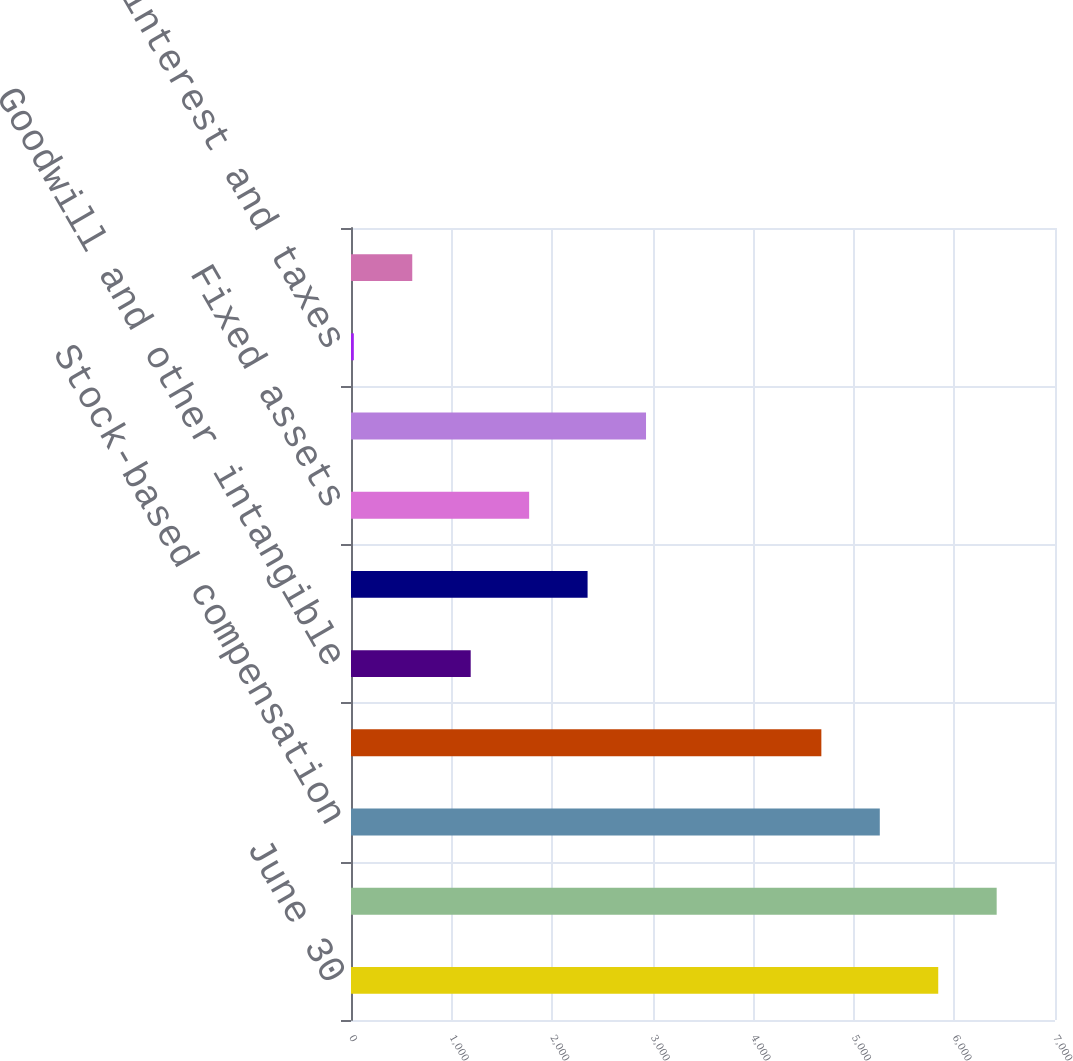Convert chart. <chart><loc_0><loc_0><loc_500><loc_500><bar_chart><fcel>June 30<fcel>Pension and postretirement<fcel>Stock-based compensation<fcel>Loss and other carryforwards<fcel>Goodwill and other intangible<fcel>Accrued marketing and<fcel>Fixed assets<fcel>Unrealized loss on financial<fcel>Accrued interest and taxes<fcel>Inventory<nl><fcel>5839<fcel>6420.1<fcel>5257.9<fcel>4676.8<fcel>1190.2<fcel>2352.4<fcel>1771.3<fcel>2933.5<fcel>28<fcel>609.1<nl></chart> 